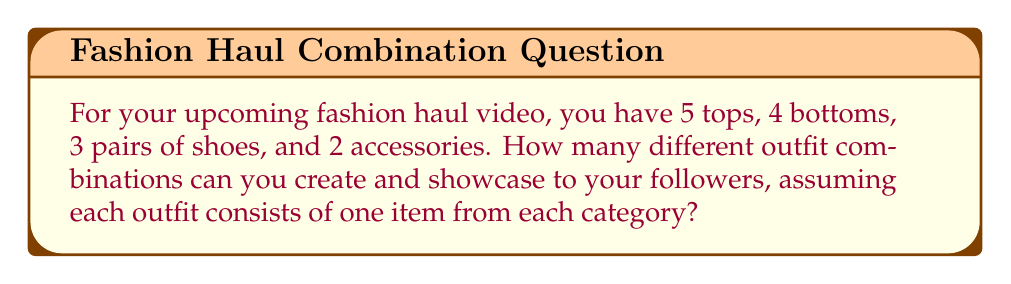Could you help me with this problem? Let's break this down step-by-step:

1. We need to calculate the number of ways to choose one item from each category.

2. For each category, we have:
   - Tops: 5 choices
   - Bottoms: 4 choices
   - Shoes: 3 choices
   - Accessories: 2 choices

3. We want to find the total number of possible combinations. In this case, we're using the multiplication principle of counting.

4. The multiplication principle states that if we have $m$ ways of doing something and $n$ ways of doing another thing, then there are $m \times n$ ways of doing both things.

5. Applying this principle to our problem:

   $$\text{Total combinations} = 5 \times 4 \times 3 \times 2$$

6. Let's calculate:
   $$5 \times 4 \times 3 \times 2 = 120$$

Therefore, you can create and showcase 120 different outfit combinations in your fashion haul video.
Answer: 120 